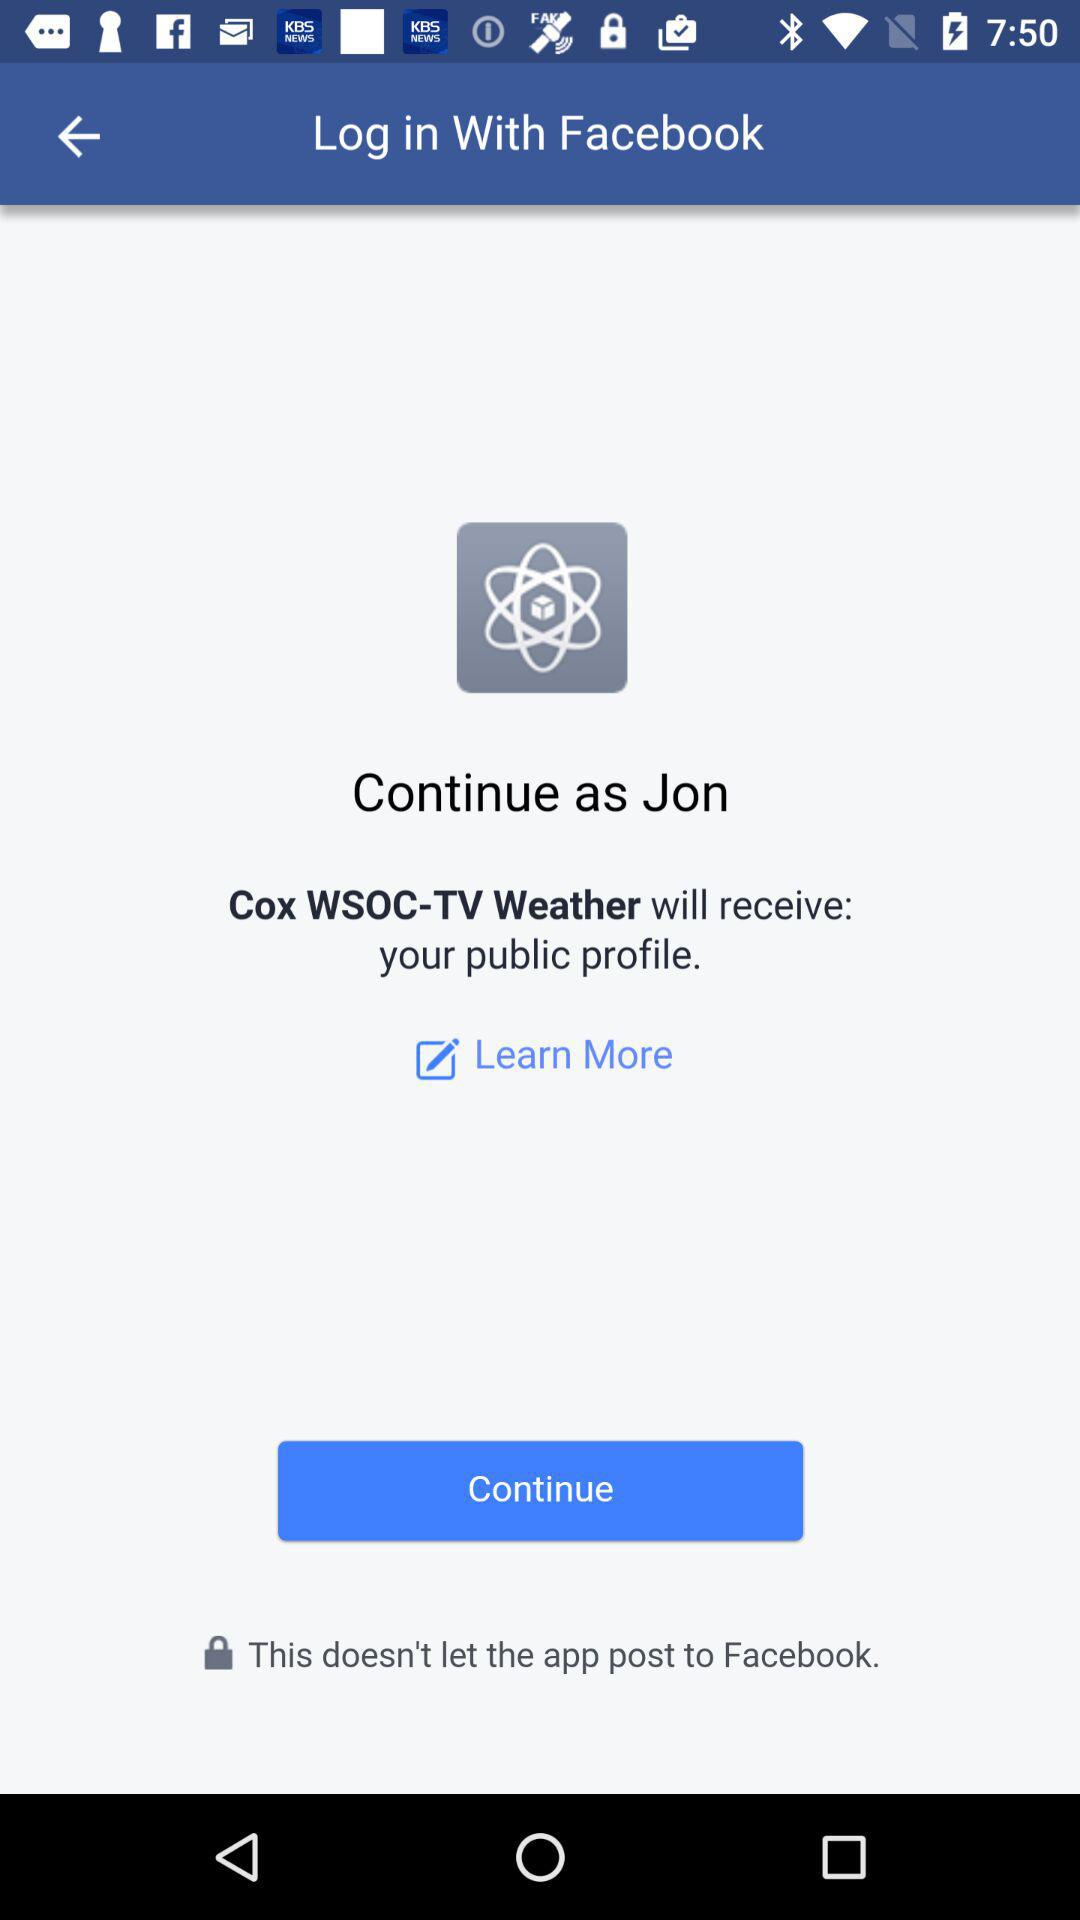Which email address will "Cox WSOC-TV Weather" have access to?
When the provided information is insufficient, respond with <no answer>. <no answer> 